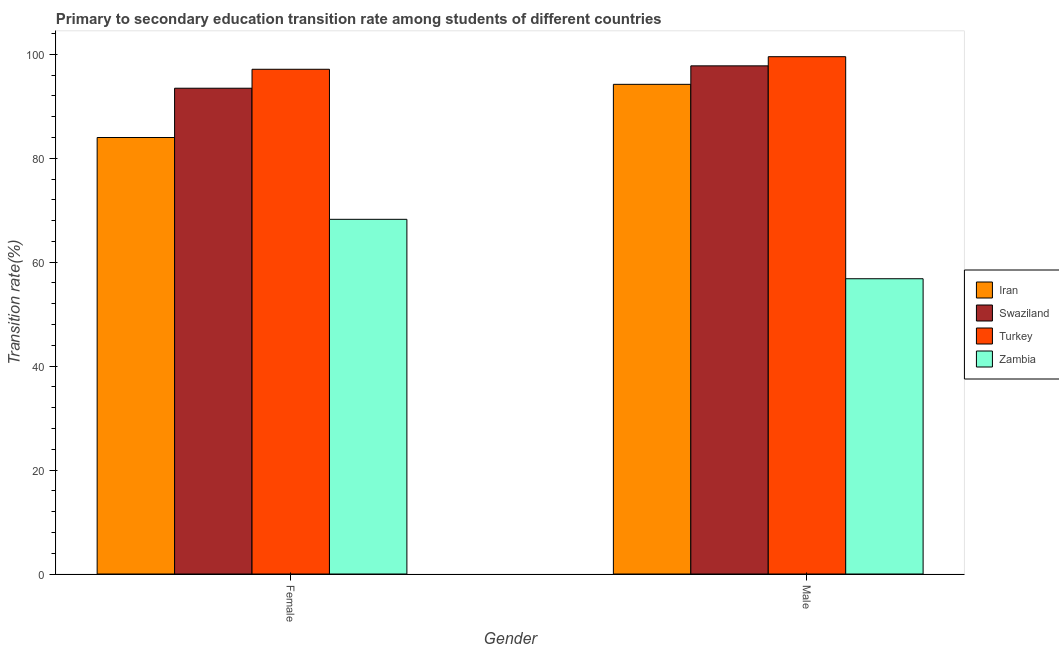How many groups of bars are there?
Provide a short and direct response. 2. Are the number of bars per tick equal to the number of legend labels?
Offer a terse response. Yes. Are the number of bars on each tick of the X-axis equal?
Offer a terse response. Yes. How many bars are there on the 1st tick from the left?
Make the answer very short. 4. What is the label of the 2nd group of bars from the left?
Ensure brevity in your answer.  Male. What is the transition rate among female students in Iran?
Your response must be concise. 83.99. Across all countries, what is the maximum transition rate among female students?
Offer a very short reply. 97.12. Across all countries, what is the minimum transition rate among female students?
Your answer should be very brief. 68.25. In which country was the transition rate among female students minimum?
Make the answer very short. Zambia. What is the total transition rate among female students in the graph?
Provide a short and direct response. 342.83. What is the difference between the transition rate among male students in Turkey and that in Zambia?
Offer a terse response. 42.73. What is the difference between the transition rate among male students in Swaziland and the transition rate among female students in Iran?
Provide a short and direct response. 13.79. What is the average transition rate among female students per country?
Your response must be concise. 85.71. What is the difference between the transition rate among male students and transition rate among female students in Turkey?
Your answer should be very brief. 2.42. In how many countries, is the transition rate among male students greater than 68 %?
Your response must be concise. 3. What is the ratio of the transition rate among male students in Zambia to that in Swaziland?
Provide a short and direct response. 0.58. Is the transition rate among female students in Swaziland less than that in Turkey?
Provide a succinct answer. Yes. What does the 1st bar from the left in Female represents?
Your response must be concise. Iran. What does the 4th bar from the right in Female represents?
Provide a succinct answer. Iran. What is the difference between two consecutive major ticks on the Y-axis?
Provide a short and direct response. 20. Does the graph contain any zero values?
Your answer should be very brief. No. How are the legend labels stacked?
Your response must be concise. Vertical. What is the title of the graph?
Provide a succinct answer. Primary to secondary education transition rate among students of different countries. What is the label or title of the X-axis?
Your response must be concise. Gender. What is the label or title of the Y-axis?
Give a very brief answer. Transition rate(%). What is the Transition rate(%) of Iran in Female?
Offer a very short reply. 83.99. What is the Transition rate(%) of Swaziland in Female?
Your response must be concise. 93.47. What is the Transition rate(%) in Turkey in Female?
Provide a succinct answer. 97.12. What is the Transition rate(%) in Zambia in Female?
Your response must be concise. 68.25. What is the Transition rate(%) in Iran in Male?
Keep it short and to the point. 94.22. What is the Transition rate(%) of Swaziland in Male?
Offer a very short reply. 97.78. What is the Transition rate(%) of Turkey in Male?
Ensure brevity in your answer.  99.54. What is the Transition rate(%) of Zambia in Male?
Give a very brief answer. 56.81. Across all Gender, what is the maximum Transition rate(%) in Iran?
Your answer should be compact. 94.22. Across all Gender, what is the maximum Transition rate(%) of Swaziland?
Make the answer very short. 97.78. Across all Gender, what is the maximum Transition rate(%) of Turkey?
Your response must be concise. 99.54. Across all Gender, what is the maximum Transition rate(%) in Zambia?
Your answer should be compact. 68.25. Across all Gender, what is the minimum Transition rate(%) in Iran?
Ensure brevity in your answer.  83.99. Across all Gender, what is the minimum Transition rate(%) in Swaziland?
Keep it short and to the point. 93.47. Across all Gender, what is the minimum Transition rate(%) in Turkey?
Offer a terse response. 97.12. Across all Gender, what is the minimum Transition rate(%) in Zambia?
Ensure brevity in your answer.  56.81. What is the total Transition rate(%) of Iran in the graph?
Your answer should be very brief. 178.21. What is the total Transition rate(%) in Swaziland in the graph?
Your answer should be compact. 191.25. What is the total Transition rate(%) in Turkey in the graph?
Your answer should be very brief. 196.66. What is the total Transition rate(%) in Zambia in the graph?
Keep it short and to the point. 125.06. What is the difference between the Transition rate(%) in Iran in Female and that in Male?
Provide a short and direct response. -10.23. What is the difference between the Transition rate(%) of Swaziland in Female and that in Male?
Ensure brevity in your answer.  -4.31. What is the difference between the Transition rate(%) of Turkey in Female and that in Male?
Give a very brief answer. -2.42. What is the difference between the Transition rate(%) of Zambia in Female and that in Male?
Make the answer very short. 11.44. What is the difference between the Transition rate(%) of Iran in Female and the Transition rate(%) of Swaziland in Male?
Offer a very short reply. -13.79. What is the difference between the Transition rate(%) of Iran in Female and the Transition rate(%) of Turkey in Male?
Make the answer very short. -15.55. What is the difference between the Transition rate(%) of Iran in Female and the Transition rate(%) of Zambia in Male?
Offer a very short reply. 27.18. What is the difference between the Transition rate(%) in Swaziland in Female and the Transition rate(%) in Turkey in Male?
Your response must be concise. -6.07. What is the difference between the Transition rate(%) of Swaziland in Female and the Transition rate(%) of Zambia in Male?
Keep it short and to the point. 36.66. What is the difference between the Transition rate(%) in Turkey in Female and the Transition rate(%) in Zambia in Male?
Offer a very short reply. 40.31. What is the average Transition rate(%) in Iran per Gender?
Ensure brevity in your answer.  89.11. What is the average Transition rate(%) of Swaziland per Gender?
Provide a succinct answer. 95.62. What is the average Transition rate(%) of Turkey per Gender?
Your response must be concise. 98.33. What is the average Transition rate(%) of Zambia per Gender?
Provide a succinct answer. 62.53. What is the difference between the Transition rate(%) of Iran and Transition rate(%) of Swaziland in Female?
Offer a terse response. -9.48. What is the difference between the Transition rate(%) in Iran and Transition rate(%) in Turkey in Female?
Offer a very short reply. -13.13. What is the difference between the Transition rate(%) of Iran and Transition rate(%) of Zambia in Female?
Make the answer very short. 15.74. What is the difference between the Transition rate(%) of Swaziland and Transition rate(%) of Turkey in Female?
Offer a terse response. -3.65. What is the difference between the Transition rate(%) in Swaziland and Transition rate(%) in Zambia in Female?
Ensure brevity in your answer.  25.22. What is the difference between the Transition rate(%) in Turkey and Transition rate(%) in Zambia in Female?
Offer a terse response. 28.87. What is the difference between the Transition rate(%) of Iran and Transition rate(%) of Swaziland in Male?
Keep it short and to the point. -3.56. What is the difference between the Transition rate(%) of Iran and Transition rate(%) of Turkey in Male?
Give a very brief answer. -5.32. What is the difference between the Transition rate(%) of Iran and Transition rate(%) of Zambia in Male?
Your response must be concise. 37.41. What is the difference between the Transition rate(%) of Swaziland and Transition rate(%) of Turkey in Male?
Your answer should be compact. -1.76. What is the difference between the Transition rate(%) in Swaziland and Transition rate(%) in Zambia in Male?
Give a very brief answer. 40.96. What is the difference between the Transition rate(%) in Turkey and Transition rate(%) in Zambia in Male?
Provide a succinct answer. 42.73. What is the ratio of the Transition rate(%) of Iran in Female to that in Male?
Your answer should be compact. 0.89. What is the ratio of the Transition rate(%) of Swaziland in Female to that in Male?
Provide a succinct answer. 0.96. What is the ratio of the Transition rate(%) of Turkey in Female to that in Male?
Ensure brevity in your answer.  0.98. What is the ratio of the Transition rate(%) of Zambia in Female to that in Male?
Keep it short and to the point. 1.2. What is the difference between the highest and the second highest Transition rate(%) in Iran?
Make the answer very short. 10.23. What is the difference between the highest and the second highest Transition rate(%) of Swaziland?
Offer a very short reply. 4.31. What is the difference between the highest and the second highest Transition rate(%) of Turkey?
Offer a very short reply. 2.42. What is the difference between the highest and the second highest Transition rate(%) in Zambia?
Provide a succinct answer. 11.44. What is the difference between the highest and the lowest Transition rate(%) of Iran?
Your answer should be very brief. 10.23. What is the difference between the highest and the lowest Transition rate(%) in Swaziland?
Make the answer very short. 4.31. What is the difference between the highest and the lowest Transition rate(%) in Turkey?
Your answer should be very brief. 2.42. What is the difference between the highest and the lowest Transition rate(%) in Zambia?
Ensure brevity in your answer.  11.44. 